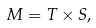<formula> <loc_0><loc_0><loc_500><loc_500>M = T \times S ,</formula> 